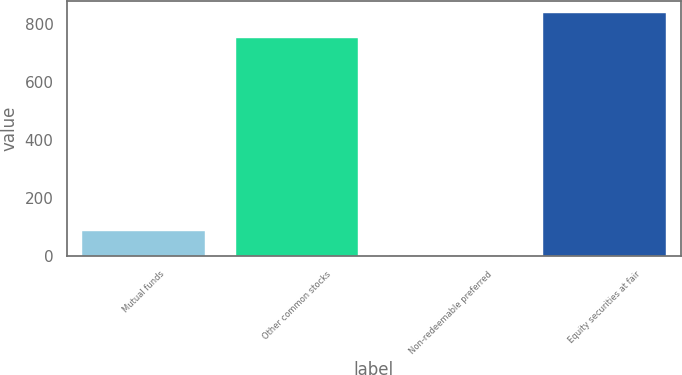Convert chart. <chart><loc_0><loc_0><loc_500><loc_500><bar_chart><fcel>Mutual funds<fcel>Other common stocks<fcel>Non-redeemable preferred<fcel>Equity securities at fair<nl><fcel>87.96<fcel>751<fcel>4.62<fcel>838<nl></chart> 